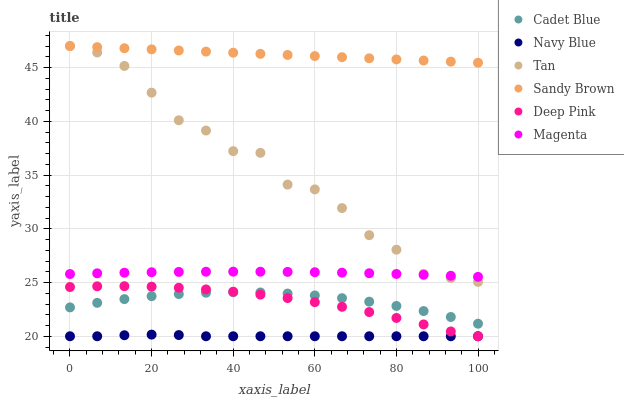Does Navy Blue have the minimum area under the curve?
Answer yes or no. Yes. Does Sandy Brown have the maximum area under the curve?
Answer yes or no. Yes. Does Deep Pink have the minimum area under the curve?
Answer yes or no. No. Does Deep Pink have the maximum area under the curve?
Answer yes or no. No. Is Sandy Brown the smoothest?
Answer yes or no. Yes. Is Tan the roughest?
Answer yes or no. Yes. Is Navy Blue the smoothest?
Answer yes or no. No. Is Navy Blue the roughest?
Answer yes or no. No. Does Navy Blue have the lowest value?
Answer yes or no. Yes. Does Tan have the lowest value?
Answer yes or no. No. Does Sandy Brown have the highest value?
Answer yes or no. Yes. Does Deep Pink have the highest value?
Answer yes or no. No. Is Navy Blue less than Sandy Brown?
Answer yes or no. Yes. Is Sandy Brown greater than Cadet Blue?
Answer yes or no. Yes. Does Deep Pink intersect Navy Blue?
Answer yes or no. Yes. Is Deep Pink less than Navy Blue?
Answer yes or no. No. Is Deep Pink greater than Navy Blue?
Answer yes or no. No. Does Navy Blue intersect Sandy Brown?
Answer yes or no. No. 